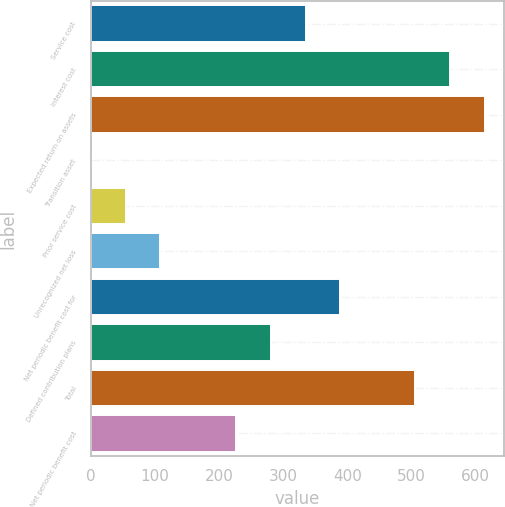<chart> <loc_0><loc_0><loc_500><loc_500><bar_chart><fcel>Service cost<fcel>Interest cost<fcel>Expected return on assets<fcel>Transition asset<fcel>Prior service cost<fcel>Unrecognized net loss<fcel>Net periodic benefit cost for<fcel>Defined contribution plans<fcel>Total<fcel>Net periodic benefit cost<nl><fcel>334.6<fcel>559.8<fcel>613.6<fcel>1<fcel>54.8<fcel>108.6<fcel>388.4<fcel>280.8<fcel>506<fcel>227<nl></chart> 